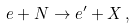Convert formula to latex. <formula><loc_0><loc_0><loc_500><loc_500>e + N \rightarrow e ^ { \prime } + X \, ,</formula> 